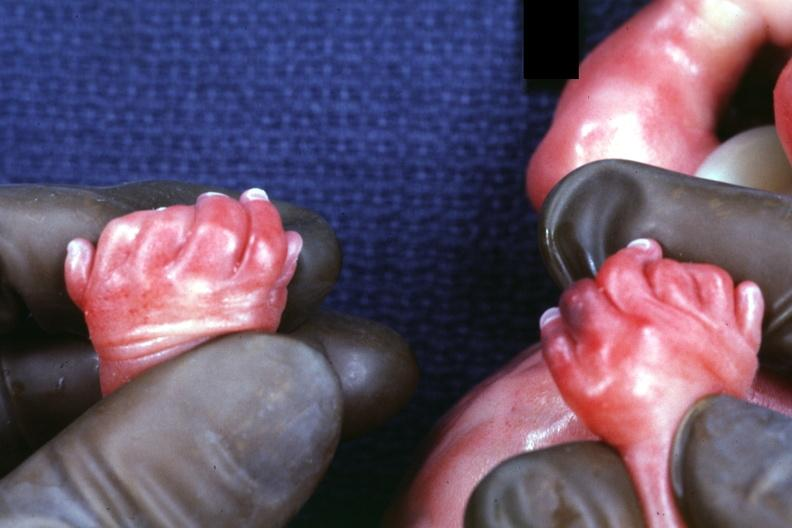re extremities present?
Answer the question using a single word or phrase. Yes 